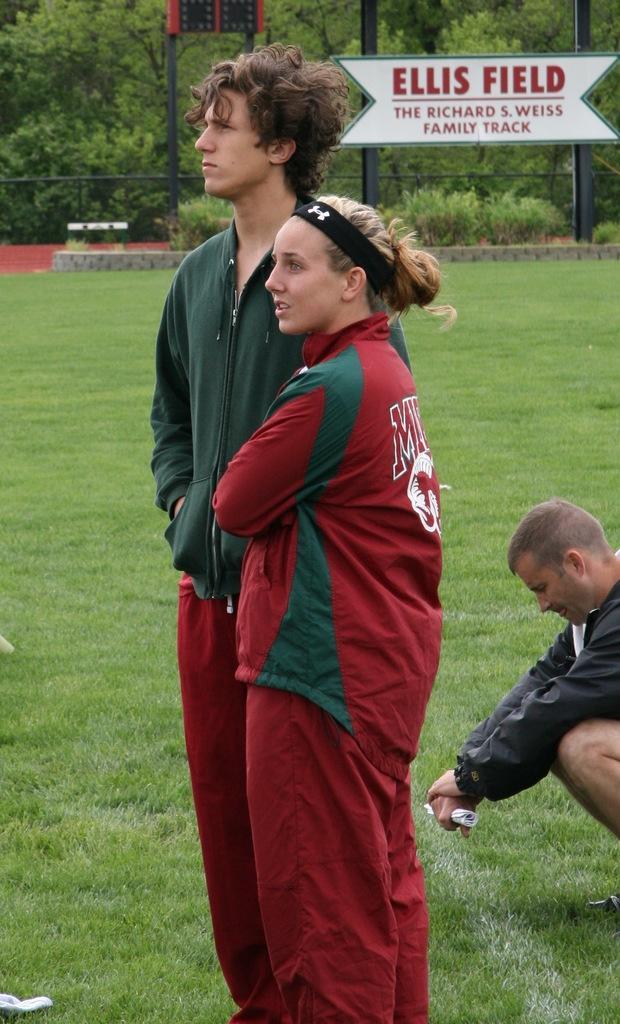Please provide a concise description of this image. In this image we can see a man and a woman standing on the ground and a man is sitting on the ground. In the background we can see iron poles, information board and trees. 